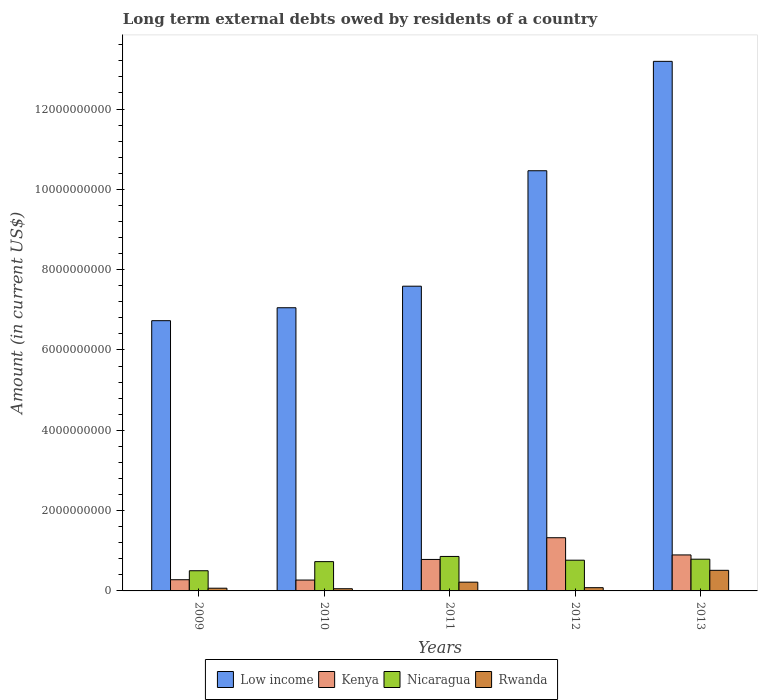How many different coloured bars are there?
Keep it short and to the point. 4. How many bars are there on the 2nd tick from the left?
Your answer should be very brief. 4. What is the label of the 5th group of bars from the left?
Your answer should be compact. 2013. What is the amount of long-term external debts owed by residents in Kenya in 2013?
Your answer should be very brief. 8.96e+08. Across all years, what is the maximum amount of long-term external debts owed by residents in Low income?
Offer a terse response. 1.32e+1. Across all years, what is the minimum amount of long-term external debts owed by residents in Nicaragua?
Give a very brief answer. 5.03e+08. In which year was the amount of long-term external debts owed by residents in Kenya maximum?
Keep it short and to the point. 2012. What is the total amount of long-term external debts owed by residents in Low income in the graph?
Provide a succinct answer. 4.50e+1. What is the difference between the amount of long-term external debts owed by residents in Nicaragua in 2011 and that in 2013?
Provide a succinct answer. 6.83e+07. What is the difference between the amount of long-term external debts owed by residents in Kenya in 2011 and the amount of long-term external debts owed by residents in Rwanda in 2010?
Ensure brevity in your answer.  7.29e+08. What is the average amount of long-term external debts owed by residents in Low income per year?
Keep it short and to the point. 9.00e+09. In the year 2010, what is the difference between the amount of long-term external debts owed by residents in Low income and amount of long-term external debts owed by residents in Nicaragua?
Your answer should be very brief. 6.32e+09. In how many years, is the amount of long-term external debts owed by residents in Rwanda greater than 1200000000 US$?
Offer a terse response. 0. What is the ratio of the amount of long-term external debts owed by residents in Rwanda in 2009 to that in 2010?
Offer a very short reply. 1.24. What is the difference between the highest and the second highest amount of long-term external debts owed by residents in Kenya?
Give a very brief answer. 4.28e+08. What is the difference between the highest and the lowest amount of long-term external debts owed by residents in Kenya?
Make the answer very short. 1.05e+09. What does the 1st bar from the left in 2011 represents?
Provide a succinct answer. Low income. What does the 3rd bar from the right in 2010 represents?
Your answer should be very brief. Kenya. Is it the case that in every year, the sum of the amount of long-term external debts owed by residents in Kenya and amount of long-term external debts owed by residents in Rwanda is greater than the amount of long-term external debts owed by residents in Low income?
Make the answer very short. No. What is the difference between two consecutive major ticks on the Y-axis?
Make the answer very short. 2.00e+09. Are the values on the major ticks of Y-axis written in scientific E-notation?
Offer a terse response. No. Does the graph contain any zero values?
Ensure brevity in your answer.  No. Does the graph contain grids?
Your response must be concise. No. Where does the legend appear in the graph?
Make the answer very short. Bottom center. How many legend labels are there?
Make the answer very short. 4. What is the title of the graph?
Your response must be concise. Long term external debts owed by residents of a country. Does "Uganda" appear as one of the legend labels in the graph?
Give a very brief answer. No. What is the label or title of the X-axis?
Make the answer very short. Years. What is the Amount (in current US$) of Low income in 2009?
Your answer should be very brief. 6.73e+09. What is the Amount (in current US$) in Kenya in 2009?
Offer a very short reply. 2.79e+08. What is the Amount (in current US$) in Nicaragua in 2009?
Offer a terse response. 5.03e+08. What is the Amount (in current US$) of Rwanda in 2009?
Provide a succinct answer. 6.75e+07. What is the Amount (in current US$) in Low income in 2010?
Make the answer very short. 7.05e+09. What is the Amount (in current US$) of Kenya in 2010?
Your answer should be compact. 2.71e+08. What is the Amount (in current US$) of Nicaragua in 2010?
Ensure brevity in your answer.  7.29e+08. What is the Amount (in current US$) of Rwanda in 2010?
Offer a very short reply. 5.46e+07. What is the Amount (in current US$) of Low income in 2011?
Your answer should be very brief. 7.59e+09. What is the Amount (in current US$) of Kenya in 2011?
Offer a terse response. 7.84e+08. What is the Amount (in current US$) in Nicaragua in 2011?
Keep it short and to the point. 8.59e+08. What is the Amount (in current US$) in Rwanda in 2011?
Provide a short and direct response. 2.18e+08. What is the Amount (in current US$) in Low income in 2012?
Your answer should be very brief. 1.05e+1. What is the Amount (in current US$) of Kenya in 2012?
Your response must be concise. 1.32e+09. What is the Amount (in current US$) in Nicaragua in 2012?
Provide a succinct answer. 7.65e+08. What is the Amount (in current US$) in Rwanda in 2012?
Offer a terse response. 8.08e+07. What is the Amount (in current US$) of Low income in 2013?
Ensure brevity in your answer.  1.32e+1. What is the Amount (in current US$) of Kenya in 2013?
Provide a short and direct response. 8.96e+08. What is the Amount (in current US$) in Nicaragua in 2013?
Your answer should be compact. 7.90e+08. What is the Amount (in current US$) in Rwanda in 2013?
Your response must be concise. 5.13e+08. Across all years, what is the maximum Amount (in current US$) of Low income?
Ensure brevity in your answer.  1.32e+1. Across all years, what is the maximum Amount (in current US$) in Kenya?
Provide a short and direct response. 1.32e+09. Across all years, what is the maximum Amount (in current US$) in Nicaragua?
Offer a very short reply. 8.59e+08. Across all years, what is the maximum Amount (in current US$) in Rwanda?
Your response must be concise. 5.13e+08. Across all years, what is the minimum Amount (in current US$) of Low income?
Offer a very short reply. 6.73e+09. Across all years, what is the minimum Amount (in current US$) in Kenya?
Provide a succinct answer. 2.71e+08. Across all years, what is the minimum Amount (in current US$) of Nicaragua?
Provide a short and direct response. 5.03e+08. Across all years, what is the minimum Amount (in current US$) in Rwanda?
Offer a terse response. 5.46e+07. What is the total Amount (in current US$) of Low income in the graph?
Make the answer very short. 4.50e+1. What is the total Amount (in current US$) of Kenya in the graph?
Your answer should be compact. 3.55e+09. What is the total Amount (in current US$) of Nicaragua in the graph?
Give a very brief answer. 3.65e+09. What is the total Amount (in current US$) of Rwanda in the graph?
Offer a terse response. 9.34e+08. What is the difference between the Amount (in current US$) of Low income in 2009 and that in 2010?
Offer a terse response. -3.22e+08. What is the difference between the Amount (in current US$) in Kenya in 2009 and that in 2010?
Your answer should be compact. 7.98e+06. What is the difference between the Amount (in current US$) in Nicaragua in 2009 and that in 2010?
Your answer should be compact. -2.27e+08. What is the difference between the Amount (in current US$) of Rwanda in 2009 and that in 2010?
Give a very brief answer. 1.30e+07. What is the difference between the Amount (in current US$) of Low income in 2009 and that in 2011?
Your answer should be compact. -8.59e+08. What is the difference between the Amount (in current US$) of Kenya in 2009 and that in 2011?
Make the answer very short. -5.05e+08. What is the difference between the Amount (in current US$) in Nicaragua in 2009 and that in 2011?
Offer a very short reply. -3.56e+08. What is the difference between the Amount (in current US$) in Rwanda in 2009 and that in 2011?
Offer a terse response. -1.51e+08. What is the difference between the Amount (in current US$) of Low income in 2009 and that in 2012?
Offer a terse response. -3.73e+09. What is the difference between the Amount (in current US$) of Kenya in 2009 and that in 2012?
Ensure brevity in your answer.  -1.05e+09. What is the difference between the Amount (in current US$) of Nicaragua in 2009 and that in 2012?
Make the answer very short. -2.62e+08. What is the difference between the Amount (in current US$) of Rwanda in 2009 and that in 2012?
Keep it short and to the point. -1.33e+07. What is the difference between the Amount (in current US$) in Low income in 2009 and that in 2013?
Your response must be concise. -6.46e+09. What is the difference between the Amount (in current US$) in Kenya in 2009 and that in 2013?
Your answer should be compact. -6.18e+08. What is the difference between the Amount (in current US$) of Nicaragua in 2009 and that in 2013?
Make the answer very short. -2.88e+08. What is the difference between the Amount (in current US$) in Rwanda in 2009 and that in 2013?
Provide a short and direct response. -4.46e+08. What is the difference between the Amount (in current US$) in Low income in 2010 and that in 2011?
Ensure brevity in your answer.  -5.36e+08. What is the difference between the Amount (in current US$) in Kenya in 2010 and that in 2011?
Your answer should be very brief. -5.13e+08. What is the difference between the Amount (in current US$) in Nicaragua in 2010 and that in 2011?
Your answer should be very brief. -1.29e+08. What is the difference between the Amount (in current US$) of Rwanda in 2010 and that in 2011?
Offer a very short reply. -1.64e+08. What is the difference between the Amount (in current US$) of Low income in 2010 and that in 2012?
Your response must be concise. -3.41e+09. What is the difference between the Amount (in current US$) in Kenya in 2010 and that in 2012?
Keep it short and to the point. -1.05e+09. What is the difference between the Amount (in current US$) in Nicaragua in 2010 and that in 2012?
Ensure brevity in your answer.  -3.56e+07. What is the difference between the Amount (in current US$) in Rwanda in 2010 and that in 2012?
Offer a very short reply. -2.62e+07. What is the difference between the Amount (in current US$) in Low income in 2010 and that in 2013?
Provide a short and direct response. -6.14e+09. What is the difference between the Amount (in current US$) of Kenya in 2010 and that in 2013?
Give a very brief answer. -6.26e+08. What is the difference between the Amount (in current US$) in Nicaragua in 2010 and that in 2013?
Make the answer very short. -6.08e+07. What is the difference between the Amount (in current US$) in Rwanda in 2010 and that in 2013?
Offer a terse response. -4.58e+08. What is the difference between the Amount (in current US$) in Low income in 2011 and that in 2012?
Your response must be concise. -2.88e+09. What is the difference between the Amount (in current US$) in Kenya in 2011 and that in 2012?
Give a very brief answer. -5.41e+08. What is the difference between the Amount (in current US$) of Nicaragua in 2011 and that in 2012?
Provide a short and direct response. 9.35e+07. What is the difference between the Amount (in current US$) in Rwanda in 2011 and that in 2012?
Your response must be concise. 1.37e+08. What is the difference between the Amount (in current US$) in Low income in 2011 and that in 2013?
Your answer should be very brief. -5.60e+09. What is the difference between the Amount (in current US$) in Kenya in 2011 and that in 2013?
Make the answer very short. -1.13e+08. What is the difference between the Amount (in current US$) in Nicaragua in 2011 and that in 2013?
Your response must be concise. 6.83e+07. What is the difference between the Amount (in current US$) of Rwanda in 2011 and that in 2013?
Provide a succinct answer. -2.95e+08. What is the difference between the Amount (in current US$) of Low income in 2012 and that in 2013?
Keep it short and to the point. -2.72e+09. What is the difference between the Amount (in current US$) in Kenya in 2012 and that in 2013?
Make the answer very short. 4.28e+08. What is the difference between the Amount (in current US$) of Nicaragua in 2012 and that in 2013?
Your answer should be very brief. -2.52e+07. What is the difference between the Amount (in current US$) in Rwanda in 2012 and that in 2013?
Offer a terse response. -4.32e+08. What is the difference between the Amount (in current US$) of Low income in 2009 and the Amount (in current US$) of Kenya in 2010?
Your answer should be very brief. 6.46e+09. What is the difference between the Amount (in current US$) of Low income in 2009 and the Amount (in current US$) of Nicaragua in 2010?
Offer a very short reply. 6.00e+09. What is the difference between the Amount (in current US$) of Low income in 2009 and the Amount (in current US$) of Rwanda in 2010?
Your answer should be very brief. 6.68e+09. What is the difference between the Amount (in current US$) of Kenya in 2009 and the Amount (in current US$) of Nicaragua in 2010?
Provide a succinct answer. -4.51e+08. What is the difference between the Amount (in current US$) of Kenya in 2009 and the Amount (in current US$) of Rwanda in 2010?
Provide a short and direct response. 2.24e+08. What is the difference between the Amount (in current US$) of Nicaragua in 2009 and the Amount (in current US$) of Rwanda in 2010?
Ensure brevity in your answer.  4.48e+08. What is the difference between the Amount (in current US$) in Low income in 2009 and the Amount (in current US$) in Kenya in 2011?
Ensure brevity in your answer.  5.95e+09. What is the difference between the Amount (in current US$) of Low income in 2009 and the Amount (in current US$) of Nicaragua in 2011?
Provide a succinct answer. 5.87e+09. What is the difference between the Amount (in current US$) in Low income in 2009 and the Amount (in current US$) in Rwanda in 2011?
Offer a very short reply. 6.51e+09. What is the difference between the Amount (in current US$) of Kenya in 2009 and the Amount (in current US$) of Nicaragua in 2011?
Offer a terse response. -5.80e+08. What is the difference between the Amount (in current US$) of Kenya in 2009 and the Amount (in current US$) of Rwanda in 2011?
Your response must be concise. 6.07e+07. What is the difference between the Amount (in current US$) in Nicaragua in 2009 and the Amount (in current US$) in Rwanda in 2011?
Your answer should be very brief. 2.85e+08. What is the difference between the Amount (in current US$) in Low income in 2009 and the Amount (in current US$) in Kenya in 2012?
Your answer should be very brief. 5.41e+09. What is the difference between the Amount (in current US$) in Low income in 2009 and the Amount (in current US$) in Nicaragua in 2012?
Your response must be concise. 5.96e+09. What is the difference between the Amount (in current US$) in Low income in 2009 and the Amount (in current US$) in Rwanda in 2012?
Offer a terse response. 6.65e+09. What is the difference between the Amount (in current US$) in Kenya in 2009 and the Amount (in current US$) in Nicaragua in 2012?
Make the answer very short. -4.86e+08. What is the difference between the Amount (in current US$) of Kenya in 2009 and the Amount (in current US$) of Rwanda in 2012?
Your answer should be very brief. 1.98e+08. What is the difference between the Amount (in current US$) of Nicaragua in 2009 and the Amount (in current US$) of Rwanda in 2012?
Offer a very short reply. 4.22e+08. What is the difference between the Amount (in current US$) of Low income in 2009 and the Amount (in current US$) of Kenya in 2013?
Your response must be concise. 5.83e+09. What is the difference between the Amount (in current US$) of Low income in 2009 and the Amount (in current US$) of Nicaragua in 2013?
Offer a very short reply. 5.94e+09. What is the difference between the Amount (in current US$) in Low income in 2009 and the Amount (in current US$) in Rwanda in 2013?
Your response must be concise. 6.22e+09. What is the difference between the Amount (in current US$) of Kenya in 2009 and the Amount (in current US$) of Nicaragua in 2013?
Offer a terse response. -5.11e+08. What is the difference between the Amount (in current US$) of Kenya in 2009 and the Amount (in current US$) of Rwanda in 2013?
Your answer should be very brief. -2.34e+08. What is the difference between the Amount (in current US$) in Nicaragua in 2009 and the Amount (in current US$) in Rwanda in 2013?
Your response must be concise. -1.03e+07. What is the difference between the Amount (in current US$) of Low income in 2010 and the Amount (in current US$) of Kenya in 2011?
Provide a succinct answer. 6.27e+09. What is the difference between the Amount (in current US$) in Low income in 2010 and the Amount (in current US$) in Nicaragua in 2011?
Provide a succinct answer. 6.19e+09. What is the difference between the Amount (in current US$) in Low income in 2010 and the Amount (in current US$) in Rwanda in 2011?
Your answer should be compact. 6.83e+09. What is the difference between the Amount (in current US$) in Kenya in 2010 and the Amount (in current US$) in Nicaragua in 2011?
Your answer should be compact. -5.88e+08. What is the difference between the Amount (in current US$) in Kenya in 2010 and the Amount (in current US$) in Rwanda in 2011?
Provide a succinct answer. 5.27e+07. What is the difference between the Amount (in current US$) of Nicaragua in 2010 and the Amount (in current US$) of Rwanda in 2011?
Give a very brief answer. 5.11e+08. What is the difference between the Amount (in current US$) in Low income in 2010 and the Amount (in current US$) in Kenya in 2012?
Provide a succinct answer. 5.73e+09. What is the difference between the Amount (in current US$) in Low income in 2010 and the Amount (in current US$) in Nicaragua in 2012?
Ensure brevity in your answer.  6.29e+09. What is the difference between the Amount (in current US$) in Low income in 2010 and the Amount (in current US$) in Rwanda in 2012?
Your answer should be compact. 6.97e+09. What is the difference between the Amount (in current US$) of Kenya in 2010 and the Amount (in current US$) of Nicaragua in 2012?
Your answer should be very brief. -4.94e+08. What is the difference between the Amount (in current US$) in Kenya in 2010 and the Amount (in current US$) in Rwanda in 2012?
Give a very brief answer. 1.90e+08. What is the difference between the Amount (in current US$) of Nicaragua in 2010 and the Amount (in current US$) of Rwanda in 2012?
Give a very brief answer. 6.49e+08. What is the difference between the Amount (in current US$) in Low income in 2010 and the Amount (in current US$) in Kenya in 2013?
Ensure brevity in your answer.  6.16e+09. What is the difference between the Amount (in current US$) in Low income in 2010 and the Amount (in current US$) in Nicaragua in 2013?
Ensure brevity in your answer.  6.26e+09. What is the difference between the Amount (in current US$) of Low income in 2010 and the Amount (in current US$) of Rwanda in 2013?
Provide a short and direct response. 6.54e+09. What is the difference between the Amount (in current US$) in Kenya in 2010 and the Amount (in current US$) in Nicaragua in 2013?
Provide a short and direct response. -5.19e+08. What is the difference between the Amount (in current US$) in Kenya in 2010 and the Amount (in current US$) in Rwanda in 2013?
Your response must be concise. -2.42e+08. What is the difference between the Amount (in current US$) in Nicaragua in 2010 and the Amount (in current US$) in Rwanda in 2013?
Your response must be concise. 2.16e+08. What is the difference between the Amount (in current US$) of Low income in 2011 and the Amount (in current US$) of Kenya in 2012?
Your response must be concise. 6.26e+09. What is the difference between the Amount (in current US$) in Low income in 2011 and the Amount (in current US$) in Nicaragua in 2012?
Offer a terse response. 6.82e+09. What is the difference between the Amount (in current US$) in Low income in 2011 and the Amount (in current US$) in Rwanda in 2012?
Give a very brief answer. 7.51e+09. What is the difference between the Amount (in current US$) in Kenya in 2011 and the Amount (in current US$) in Nicaragua in 2012?
Ensure brevity in your answer.  1.86e+07. What is the difference between the Amount (in current US$) of Kenya in 2011 and the Amount (in current US$) of Rwanda in 2012?
Keep it short and to the point. 7.03e+08. What is the difference between the Amount (in current US$) in Nicaragua in 2011 and the Amount (in current US$) in Rwanda in 2012?
Provide a short and direct response. 7.78e+08. What is the difference between the Amount (in current US$) in Low income in 2011 and the Amount (in current US$) in Kenya in 2013?
Your answer should be very brief. 6.69e+09. What is the difference between the Amount (in current US$) of Low income in 2011 and the Amount (in current US$) of Nicaragua in 2013?
Make the answer very short. 6.80e+09. What is the difference between the Amount (in current US$) in Low income in 2011 and the Amount (in current US$) in Rwanda in 2013?
Make the answer very short. 7.08e+09. What is the difference between the Amount (in current US$) in Kenya in 2011 and the Amount (in current US$) in Nicaragua in 2013?
Ensure brevity in your answer.  -6.55e+06. What is the difference between the Amount (in current US$) in Kenya in 2011 and the Amount (in current US$) in Rwanda in 2013?
Provide a succinct answer. 2.71e+08. What is the difference between the Amount (in current US$) in Nicaragua in 2011 and the Amount (in current US$) in Rwanda in 2013?
Your answer should be very brief. 3.45e+08. What is the difference between the Amount (in current US$) in Low income in 2012 and the Amount (in current US$) in Kenya in 2013?
Keep it short and to the point. 9.57e+09. What is the difference between the Amount (in current US$) in Low income in 2012 and the Amount (in current US$) in Nicaragua in 2013?
Make the answer very short. 9.67e+09. What is the difference between the Amount (in current US$) of Low income in 2012 and the Amount (in current US$) of Rwanda in 2013?
Make the answer very short. 9.95e+09. What is the difference between the Amount (in current US$) in Kenya in 2012 and the Amount (in current US$) in Nicaragua in 2013?
Keep it short and to the point. 5.34e+08. What is the difference between the Amount (in current US$) in Kenya in 2012 and the Amount (in current US$) in Rwanda in 2013?
Offer a terse response. 8.12e+08. What is the difference between the Amount (in current US$) in Nicaragua in 2012 and the Amount (in current US$) in Rwanda in 2013?
Provide a succinct answer. 2.52e+08. What is the average Amount (in current US$) of Low income per year?
Ensure brevity in your answer.  9.00e+09. What is the average Amount (in current US$) in Kenya per year?
Provide a succinct answer. 7.11e+08. What is the average Amount (in current US$) of Nicaragua per year?
Your answer should be very brief. 7.29e+08. What is the average Amount (in current US$) of Rwanda per year?
Give a very brief answer. 1.87e+08. In the year 2009, what is the difference between the Amount (in current US$) in Low income and Amount (in current US$) in Kenya?
Give a very brief answer. 6.45e+09. In the year 2009, what is the difference between the Amount (in current US$) of Low income and Amount (in current US$) of Nicaragua?
Offer a terse response. 6.23e+09. In the year 2009, what is the difference between the Amount (in current US$) of Low income and Amount (in current US$) of Rwanda?
Offer a very short reply. 6.66e+09. In the year 2009, what is the difference between the Amount (in current US$) of Kenya and Amount (in current US$) of Nicaragua?
Keep it short and to the point. -2.24e+08. In the year 2009, what is the difference between the Amount (in current US$) in Kenya and Amount (in current US$) in Rwanda?
Offer a very short reply. 2.11e+08. In the year 2009, what is the difference between the Amount (in current US$) in Nicaragua and Amount (in current US$) in Rwanda?
Give a very brief answer. 4.35e+08. In the year 2010, what is the difference between the Amount (in current US$) in Low income and Amount (in current US$) in Kenya?
Provide a short and direct response. 6.78e+09. In the year 2010, what is the difference between the Amount (in current US$) of Low income and Amount (in current US$) of Nicaragua?
Provide a short and direct response. 6.32e+09. In the year 2010, what is the difference between the Amount (in current US$) of Low income and Amount (in current US$) of Rwanda?
Provide a short and direct response. 7.00e+09. In the year 2010, what is the difference between the Amount (in current US$) in Kenya and Amount (in current US$) in Nicaragua?
Make the answer very short. -4.59e+08. In the year 2010, what is the difference between the Amount (in current US$) of Kenya and Amount (in current US$) of Rwanda?
Your answer should be very brief. 2.16e+08. In the year 2010, what is the difference between the Amount (in current US$) of Nicaragua and Amount (in current US$) of Rwanda?
Your answer should be very brief. 6.75e+08. In the year 2011, what is the difference between the Amount (in current US$) in Low income and Amount (in current US$) in Kenya?
Your response must be concise. 6.80e+09. In the year 2011, what is the difference between the Amount (in current US$) of Low income and Amount (in current US$) of Nicaragua?
Keep it short and to the point. 6.73e+09. In the year 2011, what is the difference between the Amount (in current US$) in Low income and Amount (in current US$) in Rwanda?
Make the answer very short. 7.37e+09. In the year 2011, what is the difference between the Amount (in current US$) of Kenya and Amount (in current US$) of Nicaragua?
Your answer should be compact. -7.49e+07. In the year 2011, what is the difference between the Amount (in current US$) of Kenya and Amount (in current US$) of Rwanda?
Your response must be concise. 5.66e+08. In the year 2011, what is the difference between the Amount (in current US$) of Nicaragua and Amount (in current US$) of Rwanda?
Provide a short and direct response. 6.40e+08. In the year 2012, what is the difference between the Amount (in current US$) in Low income and Amount (in current US$) in Kenya?
Offer a terse response. 9.14e+09. In the year 2012, what is the difference between the Amount (in current US$) of Low income and Amount (in current US$) of Nicaragua?
Your answer should be very brief. 9.70e+09. In the year 2012, what is the difference between the Amount (in current US$) of Low income and Amount (in current US$) of Rwanda?
Offer a terse response. 1.04e+1. In the year 2012, what is the difference between the Amount (in current US$) in Kenya and Amount (in current US$) in Nicaragua?
Make the answer very short. 5.60e+08. In the year 2012, what is the difference between the Amount (in current US$) in Kenya and Amount (in current US$) in Rwanda?
Ensure brevity in your answer.  1.24e+09. In the year 2012, what is the difference between the Amount (in current US$) in Nicaragua and Amount (in current US$) in Rwanda?
Offer a terse response. 6.84e+08. In the year 2013, what is the difference between the Amount (in current US$) of Low income and Amount (in current US$) of Kenya?
Your response must be concise. 1.23e+1. In the year 2013, what is the difference between the Amount (in current US$) of Low income and Amount (in current US$) of Nicaragua?
Give a very brief answer. 1.24e+1. In the year 2013, what is the difference between the Amount (in current US$) of Low income and Amount (in current US$) of Rwanda?
Offer a very short reply. 1.27e+1. In the year 2013, what is the difference between the Amount (in current US$) of Kenya and Amount (in current US$) of Nicaragua?
Your answer should be very brief. 1.06e+08. In the year 2013, what is the difference between the Amount (in current US$) of Kenya and Amount (in current US$) of Rwanda?
Provide a succinct answer. 3.83e+08. In the year 2013, what is the difference between the Amount (in current US$) in Nicaragua and Amount (in current US$) in Rwanda?
Your answer should be compact. 2.77e+08. What is the ratio of the Amount (in current US$) of Low income in 2009 to that in 2010?
Offer a terse response. 0.95. What is the ratio of the Amount (in current US$) in Kenya in 2009 to that in 2010?
Provide a succinct answer. 1.03. What is the ratio of the Amount (in current US$) of Nicaragua in 2009 to that in 2010?
Your answer should be compact. 0.69. What is the ratio of the Amount (in current US$) of Rwanda in 2009 to that in 2010?
Your response must be concise. 1.24. What is the ratio of the Amount (in current US$) of Low income in 2009 to that in 2011?
Your answer should be compact. 0.89. What is the ratio of the Amount (in current US$) of Kenya in 2009 to that in 2011?
Offer a terse response. 0.36. What is the ratio of the Amount (in current US$) in Nicaragua in 2009 to that in 2011?
Make the answer very short. 0.59. What is the ratio of the Amount (in current US$) of Rwanda in 2009 to that in 2011?
Make the answer very short. 0.31. What is the ratio of the Amount (in current US$) of Low income in 2009 to that in 2012?
Provide a short and direct response. 0.64. What is the ratio of the Amount (in current US$) of Kenya in 2009 to that in 2012?
Ensure brevity in your answer.  0.21. What is the ratio of the Amount (in current US$) in Nicaragua in 2009 to that in 2012?
Offer a very short reply. 0.66. What is the ratio of the Amount (in current US$) of Rwanda in 2009 to that in 2012?
Your answer should be very brief. 0.84. What is the ratio of the Amount (in current US$) in Low income in 2009 to that in 2013?
Provide a succinct answer. 0.51. What is the ratio of the Amount (in current US$) in Kenya in 2009 to that in 2013?
Your answer should be compact. 0.31. What is the ratio of the Amount (in current US$) of Nicaragua in 2009 to that in 2013?
Ensure brevity in your answer.  0.64. What is the ratio of the Amount (in current US$) of Rwanda in 2009 to that in 2013?
Your answer should be very brief. 0.13. What is the ratio of the Amount (in current US$) of Low income in 2010 to that in 2011?
Ensure brevity in your answer.  0.93. What is the ratio of the Amount (in current US$) of Kenya in 2010 to that in 2011?
Give a very brief answer. 0.35. What is the ratio of the Amount (in current US$) in Nicaragua in 2010 to that in 2011?
Offer a terse response. 0.85. What is the ratio of the Amount (in current US$) in Rwanda in 2010 to that in 2011?
Offer a very short reply. 0.25. What is the ratio of the Amount (in current US$) in Low income in 2010 to that in 2012?
Offer a very short reply. 0.67. What is the ratio of the Amount (in current US$) in Kenya in 2010 to that in 2012?
Give a very brief answer. 0.2. What is the ratio of the Amount (in current US$) of Nicaragua in 2010 to that in 2012?
Offer a very short reply. 0.95. What is the ratio of the Amount (in current US$) in Rwanda in 2010 to that in 2012?
Provide a succinct answer. 0.68. What is the ratio of the Amount (in current US$) of Low income in 2010 to that in 2013?
Provide a succinct answer. 0.53. What is the ratio of the Amount (in current US$) in Kenya in 2010 to that in 2013?
Offer a terse response. 0.3. What is the ratio of the Amount (in current US$) in Nicaragua in 2010 to that in 2013?
Provide a succinct answer. 0.92. What is the ratio of the Amount (in current US$) of Rwanda in 2010 to that in 2013?
Give a very brief answer. 0.11. What is the ratio of the Amount (in current US$) of Low income in 2011 to that in 2012?
Your answer should be very brief. 0.73. What is the ratio of the Amount (in current US$) of Kenya in 2011 to that in 2012?
Provide a short and direct response. 0.59. What is the ratio of the Amount (in current US$) in Nicaragua in 2011 to that in 2012?
Ensure brevity in your answer.  1.12. What is the ratio of the Amount (in current US$) of Rwanda in 2011 to that in 2012?
Provide a succinct answer. 2.7. What is the ratio of the Amount (in current US$) of Low income in 2011 to that in 2013?
Keep it short and to the point. 0.58. What is the ratio of the Amount (in current US$) of Kenya in 2011 to that in 2013?
Offer a very short reply. 0.87. What is the ratio of the Amount (in current US$) of Nicaragua in 2011 to that in 2013?
Give a very brief answer. 1.09. What is the ratio of the Amount (in current US$) in Rwanda in 2011 to that in 2013?
Keep it short and to the point. 0.43. What is the ratio of the Amount (in current US$) of Low income in 2012 to that in 2013?
Your response must be concise. 0.79. What is the ratio of the Amount (in current US$) in Kenya in 2012 to that in 2013?
Make the answer very short. 1.48. What is the ratio of the Amount (in current US$) of Nicaragua in 2012 to that in 2013?
Give a very brief answer. 0.97. What is the ratio of the Amount (in current US$) in Rwanda in 2012 to that in 2013?
Keep it short and to the point. 0.16. What is the difference between the highest and the second highest Amount (in current US$) in Low income?
Your response must be concise. 2.72e+09. What is the difference between the highest and the second highest Amount (in current US$) in Kenya?
Ensure brevity in your answer.  4.28e+08. What is the difference between the highest and the second highest Amount (in current US$) in Nicaragua?
Offer a terse response. 6.83e+07. What is the difference between the highest and the second highest Amount (in current US$) in Rwanda?
Ensure brevity in your answer.  2.95e+08. What is the difference between the highest and the lowest Amount (in current US$) of Low income?
Offer a very short reply. 6.46e+09. What is the difference between the highest and the lowest Amount (in current US$) in Kenya?
Keep it short and to the point. 1.05e+09. What is the difference between the highest and the lowest Amount (in current US$) of Nicaragua?
Offer a very short reply. 3.56e+08. What is the difference between the highest and the lowest Amount (in current US$) in Rwanda?
Ensure brevity in your answer.  4.58e+08. 